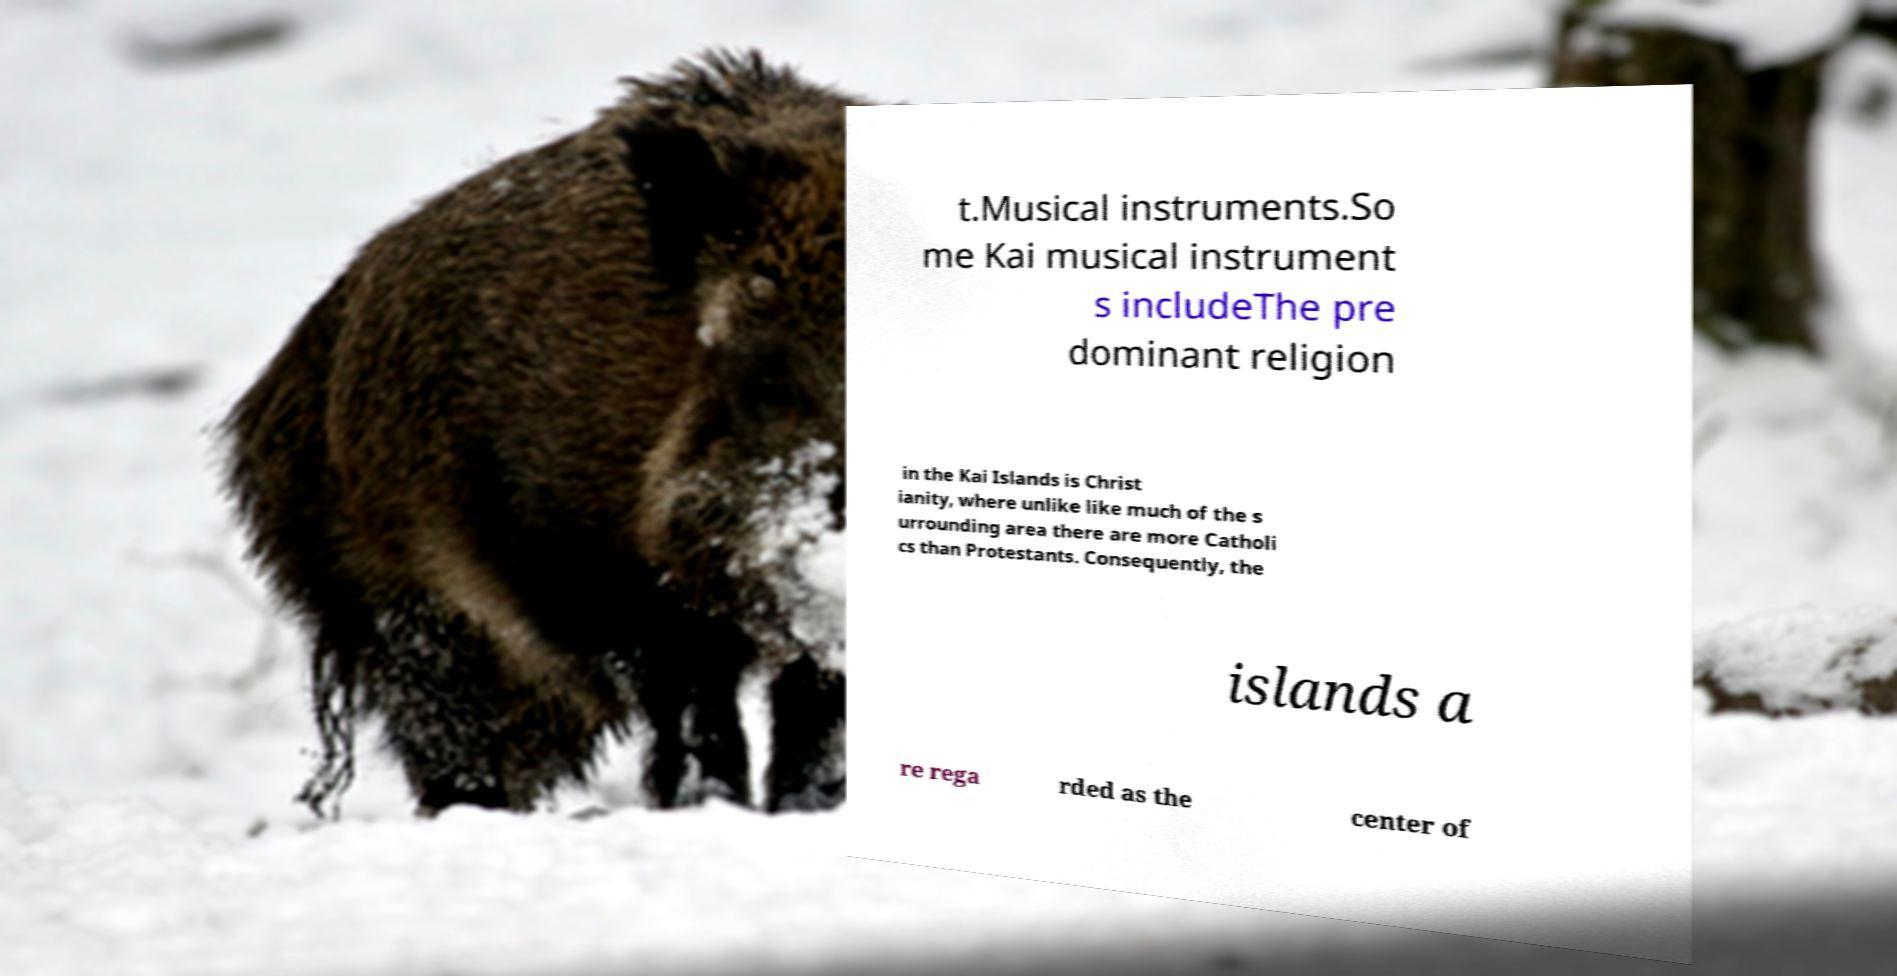Could you extract and type out the text from this image? t.Musical instruments.So me Kai musical instrument s includeThe pre dominant religion in the Kai Islands is Christ ianity, where unlike like much of the s urrounding area there are more Catholi cs than Protestants. Consequently, the islands a re rega rded as the center of 